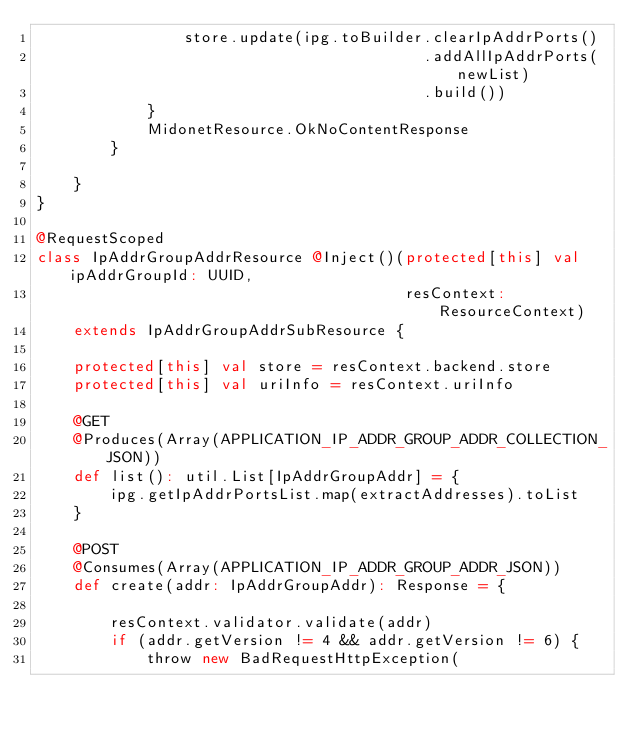Convert code to text. <code><loc_0><loc_0><loc_500><loc_500><_Scala_>                store.update(ipg.toBuilder.clearIpAddrPorts()
                                          .addAllIpAddrPorts(newList)
                                          .build())
            }
            MidonetResource.OkNoContentResponse
        }

    }
}

@RequestScoped
class IpAddrGroupAddrResource @Inject()(protected[this] val ipAddrGroupId: UUID,
                                        resContext: ResourceContext)
    extends IpAddrGroupAddrSubResource {

    protected[this] val store = resContext.backend.store
    protected[this] val uriInfo = resContext.uriInfo

    @GET
    @Produces(Array(APPLICATION_IP_ADDR_GROUP_ADDR_COLLECTION_JSON))
    def list(): util.List[IpAddrGroupAddr] = {
        ipg.getIpAddrPortsList.map(extractAddresses).toList
    }

    @POST
    @Consumes(Array(APPLICATION_IP_ADDR_GROUP_ADDR_JSON))
    def create(addr: IpAddrGroupAddr): Response = {

        resContext.validator.validate(addr)
        if (addr.getVersion != 4 && addr.getVersion != 6) {
            throw new BadRequestHttpException(</code> 